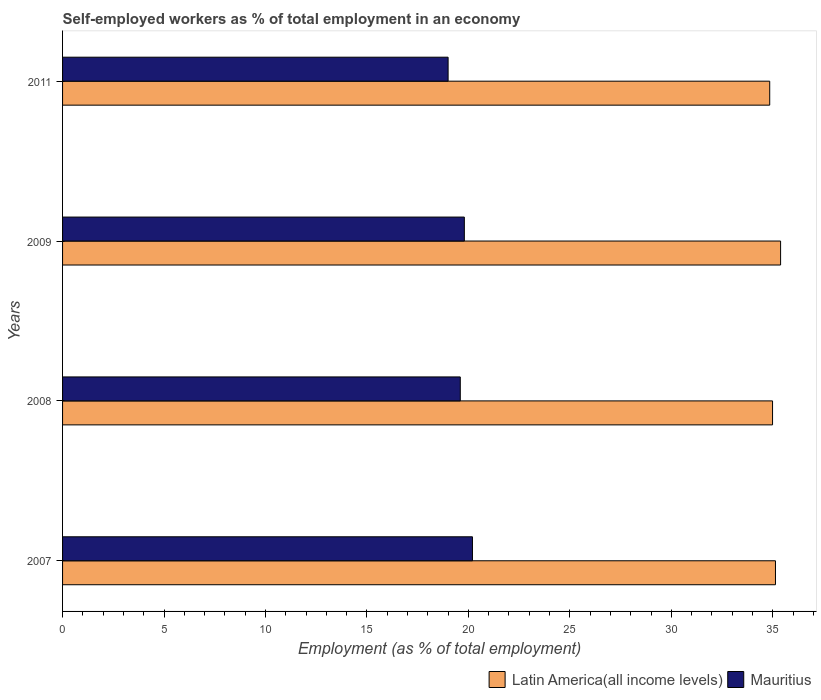How many groups of bars are there?
Offer a very short reply. 4. Are the number of bars on each tick of the Y-axis equal?
Your answer should be very brief. Yes. How many bars are there on the 4th tick from the top?
Offer a terse response. 2. What is the label of the 1st group of bars from the top?
Offer a terse response. 2011. In how many cases, is the number of bars for a given year not equal to the number of legend labels?
Offer a very short reply. 0. What is the percentage of self-employed workers in Latin America(all income levels) in 2011?
Make the answer very short. 34.85. Across all years, what is the maximum percentage of self-employed workers in Mauritius?
Keep it short and to the point. 20.2. Across all years, what is the minimum percentage of self-employed workers in Latin America(all income levels)?
Your answer should be compact. 34.85. In which year was the percentage of self-employed workers in Latin America(all income levels) minimum?
Your answer should be compact. 2011. What is the total percentage of self-employed workers in Latin America(all income levels) in the graph?
Keep it short and to the point. 140.36. What is the difference between the percentage of self-employed workers in Latin America(all income levels) in 2007 and that in 2008?
Ensure brevity in your answer.  0.14. What is the difference between the percentage of self-employed workers in Mauritius in 2008 and the percentage of self-employed workers in Latin America(all income levels) in 2007?
Your answer should be very brief. -15.53. What is the average percentage of self-employed workers in Latin America(all income levels) per year?
Provide a succinct answer. 35.09. In the year 2007, what is the difference between the percentage of self-employed workers in Latin America(all income levels) and percentage of self-employed workers in Mauritius?
Provide a succinct answer. 14.93. What is the ratio of the percentage of self-employed workers in Latin America(all income levels) in 2007 to that in 2011?
Provide a short and direct response. 1.01. Is the difference between the percentage of self-employed workers in Latin America(all income levels) in 2008 and 2009 greater than the difference between the percentage of self-employed workers in Mauritius in 2008 and 2009?
Offer a terse response. No. What is the difference between the highest and the second highest percentage of self-employed workers in Mauritius?
Keep it short and to the point. 0.4. What is the difference between the highest and the lowest percentage of self-employed workers in Latin America(all income levels)?
Make the answer very short. 0.54. In how many years, is the percentage of self-employed workers in Latin America(all income levels) greater than the average percentage of self-employed workers in Latin America(all income levels) taken over all years?
Your answer should be very brief. 2. Is the sum of the percentage of self-employed workers in Latin America(all income levels) in 2007 and 2008 greater than the maximum percentage of self-employed workers in Mauritius across all years?
Provide a short and direct response. Yes. What does the 1st bar from the top in 2007 represents?
Provide a succinct answer. Mauritius. What does the 2nd bar from the bottom in 2011 represents?
Provide a succinct answer. Mauritius. How many bars are there?
Your answer should be compact. 8. Are all the bars in the graph horizontal?
Provide a succinct answer. Yes. How many years are there in the graph?
Give a very brief answer. 4. Are the values on the major ticks of X-axis written in scientific E-notation?
Provide a short and direct response. No. Does the graph contain grids?
Provide a short and direct response. No. How are the legend labels stacked?
Ensure brevity in your answer.  Horizontal. What is the title of the graph?
Give a very brief answer. Self-employed workers as % of total employment in an economy. What is the label or title of the X-axis?
Your answer should be very brief. Employment (as % of total employment). What is the label or title of the Y-axis?
Give a very brief answer. Years. What is the Employment (as % of total employment) of Latin America(all income levels) in 2007?
Your answer should be very brief. 35.13. What is the Employment (as % of total employment) of Mauritius in 2007?
Keep it short and to the point. 20.2. What is the Employment (as % of total employment) of Latin America(all income levels) in 2008?
Your response must be concise. 34.99. What is the Employment (as % of total employment) of Mauritius in 2008?
Make the answer very short. 19.6. What is the Employment (as % of total employment) in Latin America(all income levels) in 2009?
Keep it short and to the point. 35.39. What is the Employment (as % of total employment) in Mauritius in 2009?
Your response must be concise. 19.8. What is the Employment (as % of total employment) in Latin America(all income levels) in 2011?
Give a very brief answer. 34.85. Across all years, what is the maximum Employment (as % of total employment) of Latin America(all income levels)?
Ensure brevity in your answer.  35.39. Across all years, what is the maximum Employment (as % of total employment) of Mauritius?
Your response must be concise. 20.2. Across all years, what is the minimum Employment (as % of total employment) of Latin America(all income levels)?
Keep it short and to the point. 34.85. What is the total Employment (as % of total employment) of Latin America(all income levels) in the graph?
Offer a terse response. 140.36. What is the total Employment (as % of total employment) in Mauritius in the graph?
Offer a terse response. 78.6. What is the difference between the Employment (as % of total employment) of Latin America(all income levels) in 2007 and that in 2008?
Provide a succinct answer. 0.14. What is the difference between the Employment (as % of total employment) of Mauritius in 2007 and that in 2008?
Your answer should be very brief. 0.6. What is the difference between the Employment (as % of total employment) in Latin America(all income levels) in 2007 and that in 2009?
Offer a terse response. -0.25. What is the difference between the Employment (as % of total employment) in Mauritius in 2007 and that in 2009?
Provide a short and direct response. 0.4. What is the difference between the Employment (as % of total employment) of Latin America(all income levels) in 2007 and that in 2011?
Ensure brevity in your answer.  0.28. What is the difference between the Employment (as % of total employment) in Latin America(all income levels) in 2008 and that in 2009?
Provide a short and direct response. -0.4. What is the difference between the Employment (as % of total employment) in Mauritius in 2008 and that in 2009?
Your answer should be very brief. -0.2. What is the difference between the Employment (as % of total employment) in Latin America(all income levels) in 2008 and that in 2011?
Offer a very short reply. 0.14. What is the difference between the Employment (as % of total employment) of Latin America(all income levels) in 2009 and that in 2011?
Provide a short and direct response. 0.54. What is the difference between the Employment (as % of total employment) of Latin America(all income levels) in 2007 and the Employment (as % of total employment) of Mauritius in 2008?
Your answer should be very brief. 15.53. What is the difference between the Employment (as % of total employment) in Latin America(all income levels) in 2007 and the Employment (as % of total employment) in Mauritius in 2009?
Your answer should be compact. 15.33. What is the difference between the Employment (as % of total employment) of Latin America(all income levels) in 2007 and the Employment (as % of total employment) of Mauritius in 2011?
Offer a terse response. 16.13. What is the difference between the Employment (as % of total employment) in Latin America(all income levels) in 2008 and the Employment (as % of total employment) in Mauritius in 2009?
Your answer should be compact. 15.19. What is the difference between the Employment (as % of total employment) of Latin America(all income levels) in 2008 and the Employment (as % of total employment) of Mauritius in 2011?
Offer a terse response. 15.99. What is the difference between the Employment (as % of total employment) of Latin America(all income levels) in 2009 and the Employment (as % of total employment) of Mauritius in 2011?
Make the answer very short. 16.39. What is the average Employment (as % of total employment) in Latin America(all income levels) per year?
Your answer should be very brief. 35.09. What is the average Employment (as % of total employment) in Mauritius per year?
Offer a very short reply. 19.65. In the year 2007, what is the difference between the Employment (as % of total employment) in Latin America(all income levels) and Employment (as % of total employment) in Mauritius?
Offer a very short reply. 14.93. In the year 2008, what is the difference between the Employment (as % of total employment) of Latin America(all income levels) and Employment (as % of total employment) of Mauritius?
Your answer should be compact. 15.39. In the year 2009, what is the difference between the Employment (as % of total employment) of Latin America(all income levels) and Employment (as % of total employment) of Mauritius?
Offer a terse response. 15.59. In the year 2011, what is the difference between the Employment (as % of total employment) in Latin America(all income levels) and Employment (as % of total employment) in Mauritius?
Ensure brevity in your answer.  15.85. What is the ratio of the Employment (as % of total employment) of Latin America(all income levels) in 2007 to that in 2008?
Provide a succinct answer. 1. What is the ratio of the Employment (as % of total employment) of Mauritius in 2007 to that in 2008?
Provide a succinct answer. 1.03. What is the ratio of the Employment (as % of total employment) of Latin America(all income levels) in 2007 to that in 2009?
Keep it short and to the point. 0.99. What is the ratio of the Employment (as % of total employment) in Mauritius in 2007 to that in 2009?
Your answer should be very brief. 1.02. What is the ratio of the Employment (as % of total employment) of Latin America(all income levels) in 2007 to that in 2011?
Make the answer very short. 1.01. What is the ratio of the Employment (as % of total employment) in Mauritius in 2007 to that in 2011?
Your response must be concise. 1.06. What is the ratio of the Employment (as % of total employment) of Mauritius in 2008 to that in 2009?
Your answer should be compact. 0.99. What is the ratio of the Employment (as % of total employment) in Latin America(all income levels) in 2008 to that in 2011?
Offer a terse response. 1. What is the ratio of the Employment (as % of total employment) in Mauritius in 2008 to that in 2011?
Your answer should be compact. 1.03. What is the ratio of the Employment (as % of total employment) in Latin America(all income levels) in 2009 to that in 2011?
Make the answer very short. 1.02. What is the ratio of the Employment (as % of total employment) of Mauritius in 2009 to that in 2011?
Provide a succinct answer. 1.04. What is the difference between the highest and the second highest Employment (as % of total employment) of Latin America(all income levels)?
Your response must be concise. 0.25. What is the difference between the highest and the second highest Employment (as % of total employment) in Mauritius?
Ensure brevity in your answer.  0.4. What is the difference between the highest and the lowest Employment (as % of total employment) of Latin America(all income levels)?
Offer a very short reply. 0.54. 